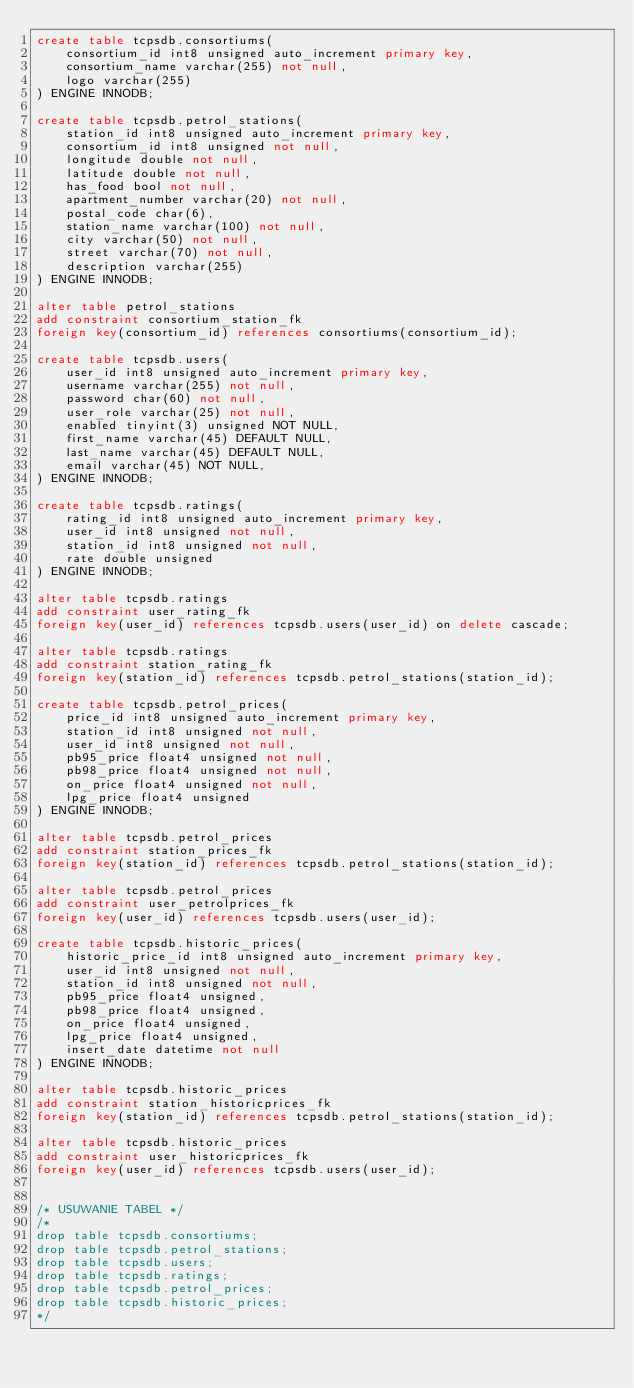Convert code to text. <code><loc_0><loc_0><loc_500><loc_500><_SQL_>create table tcpsdb.consortiums(
	consortium_id int8 unsigned auto_increment primary key,
    consortium_name varchar(255) not null,
    logo varchar(255)
) ENGINE INNODB;

create table tcpsdb.petrol_stations(
	station_id int8 unsigned auto_increment primary key,
    consortium_id int8 unsigned not null,
	longitude double not null,
    latitude double not null,
    has_food bool not null,
    apartment_number varchar(20) not null,
    postal_code char(6),
    station_name varchar(100) not null,
    city varchar(50) not null,
    street varchar(70) not null,
    description varchar(255)
) ENGINE INNODB;

alter table petrol_stations
add constraint consortium_station_fk
foreign key(consortium_id) references consortiums(consortium_id);

create table tcpsdb.users(
	user_id int8 unsigned auto_increment primary key,
    username varchar(255) not null,
	password char(60) not null,
	user_role varchar(25) not null,
	enabled tinyint(3) unsigned NOT NULL,
	first_name varchar(45) DEFAULT NULL,
	last_name varchar(45) DEFAULT NULL,
	email varchar(45) NOT NULL,
) ENGINE INNODB;

create table tcpsdb.ratings(
	rating_id int8 unsigned auto_increment primary key,
    user_id int8 unsigned not null,
    station_id int8 unsigned not null,
    rate double unsigned
) ENGINE INNODB;

alter table tcpsdb.ratings
add constraint user_rating_fk
foreign key(user_id) references tcpsdb.users(user_id) on delete cascade;

alter table tcpsdb.ratings
add constraint station_rating_fk
foreign key(station_id) references tcpsdb.petrol_stations(station_id);

create table tcpsdb.petrol_prices(
	price_id int8 unsigned auto_increment primary key,
    station_id int8 unsigned not null,
	user_id int8 unsigned not null,
    pb95_price float4 unsigned not null,
    pb98_price float4 unsigned not null,
    on_price float4 unsigned not null,
    lpg_price float4 unsigned
) ENGINE INNODB;

alter table tcpsdb.petrol_prices
add constraint station_prices_fk
foreign key(station_id) references tcpsdb.petrol_stations(station_id);

alter table tcpsdb.petrol_prices
add constraint user_petrolprices_fk
foreign key(user_id) references tcpsdb.users(user_id);

create table tcpsdb.historic_prices(
	historic_price_id int8 unsigned auto_increment primary key,
    user_id int8 unsigned not null,
    station_id int8 unsigned not null,
    pb95_price float4 unsigned,
    pb98_price float4 unsigned,
    on_price float4 unsigned,
    lpg_price float4 unsigned,
    insert_date datetime not null
) ENGINE INNODB;

alter table tcpsdb.historic_prices
add constraint station_historicprices_fk
foreign key(station_id) references tcpsdb.petrol_stations(station_id);

alter table tcpsdb.historic_prices
add constraint user_historicprices_fk
foreign key(user_id) references tcpsdb.users(user_id);


/* USUWANIE TABEL */
/*
drop table tcpsdb.consortiums;
drop table tcpsdb.petrol_stations;
drop table tcpsdb.users;
drop table tcpsdb.ratings;
drop table tcpsdb.petrol_prices;
drop table tcpsdb.historic_prices;
*/</code> 